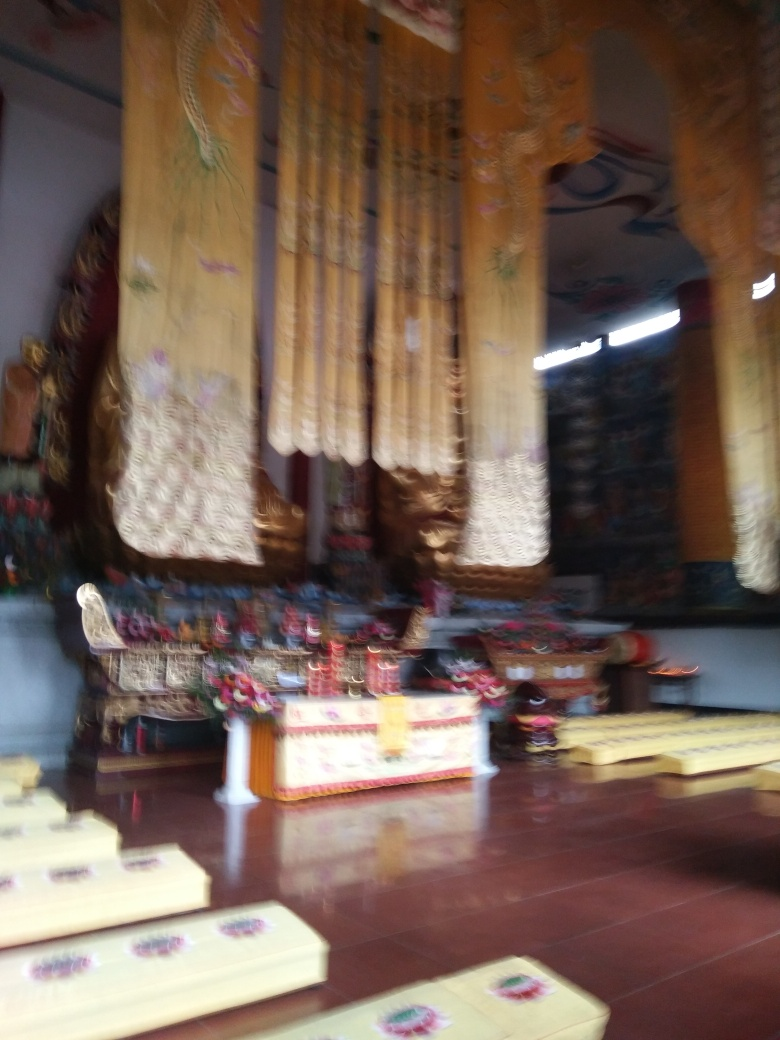How does the quality of the image affect our understanding of the details? The blurriness impairs our ability to perceive fine details, like the textures of the surfaces, exact colors, and specific objects. It leaves much to interpretation, requiring us to make educated guesses about what we're seeing and the context within which the photo was taken. 